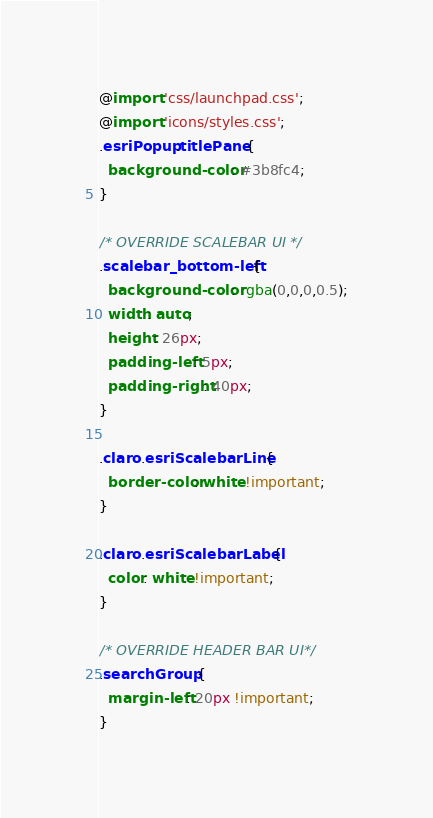Convert code to text. <code><loc_0><loc_0><loc_500><loc_500><_CSS_>@import 'css/launchpad.css';
@import 'icons/styles.css';
.esriPopup .titlePane {
  background-color: #3b8fc4;
}

/* OVERRIDE SCALEBAR UI */
.scalebar_bottom-left {
  background-color: rgba(0,0,0,0.5);
  width: auto;
  height: 26px;
  padding-left: 5px;
  padding-right: 40px;
}

.claro .esriScalebarLine {
  border-color: white !important;
}

.claro .esriScalebarLabel {
  color: white !important;
}

/* OVERRIDE HEADER BAR UI*/
.searchGroup {
  margin-left: 20px !important;
}</code> 